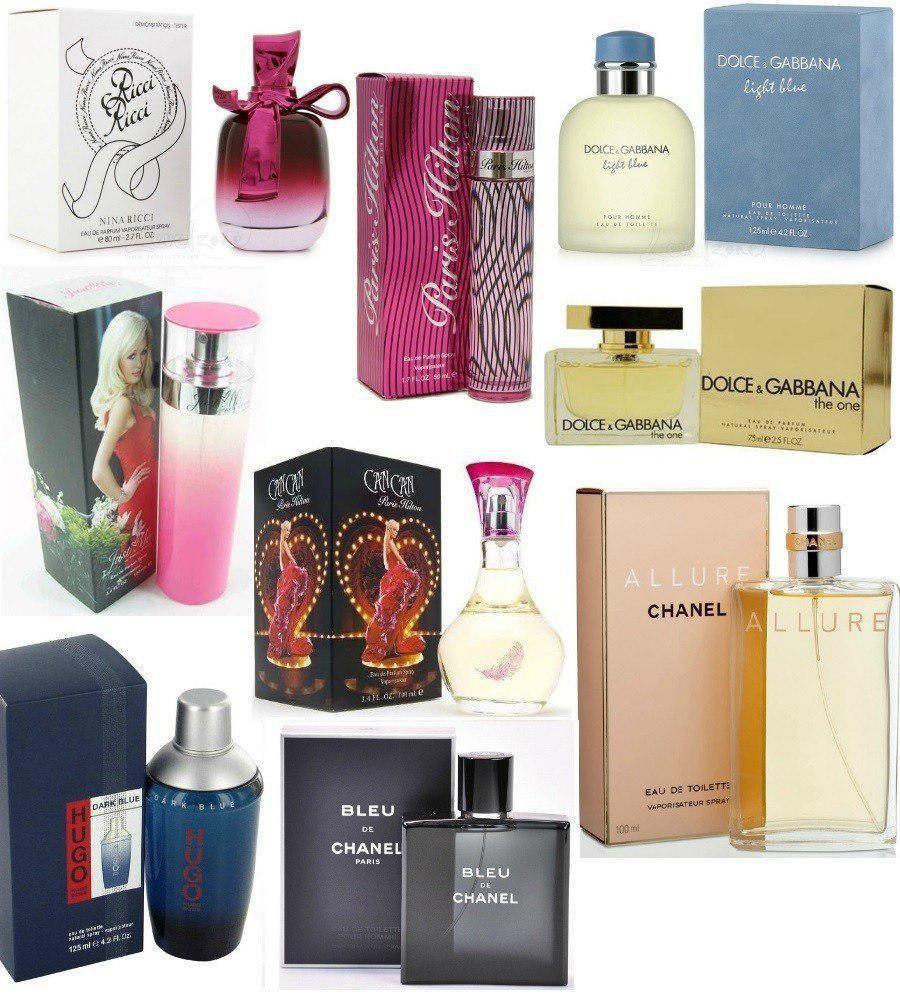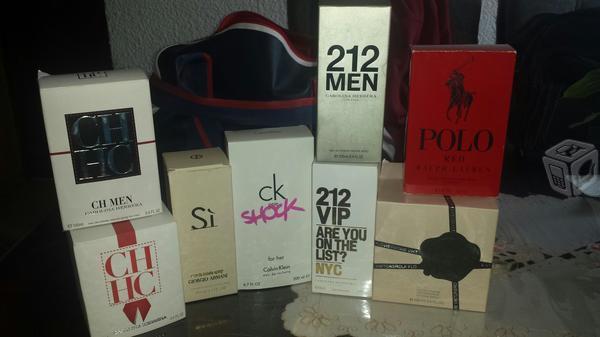The first image is the image on the left, the second image is the image on the right. Considering the images on both sides, is "In the image on the right, perfumes are stacked in front of a bag." valid? Answer yes or no. Yes. The first image is the image on the left, the second image is the image on the right. For the images shown, is this caption "The left image includes at least one round glass fragrance bottle but does not include any boxes." true? Answer yes or no. No. 